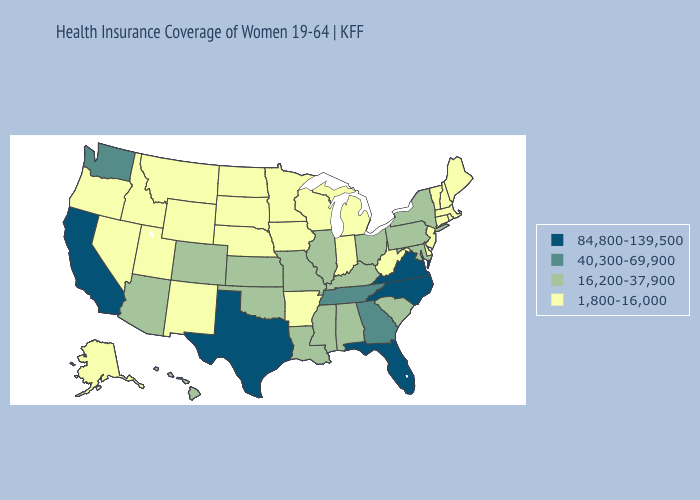What is the value of Idaho?
Quick response, please. 1,800-16,000. Does Rhode Island have the lowest value in the USA?
Give a very brief answer. Yes. Does Maine have the highest value in the USA?
Answer briefly. No. Does Connecticut have a lower value than Utah?
Keep it brief. No. Does Alabama have the lowest value in the USA?
Be succinct. No. What is the value of Nebraska?
Write a very short answer. 1,800-16,000. What is the highest value in the MidWest ?
Answer briefly. 16,200-37,900. Name the states that have a value in the range 16,200-37,900?
Be succinct. Alabama, Arizona, Colorado, Hawaii, Illinois, Kansas, Kentucky, Louisiana, Maryland, Mississippi, Missouri, New York, Ohio, Oklahoma, Pennsylvania, South Carolina. What is the value of Oregon?
Answer briefly. 1,800-16,000. What is the lowest value in states that border Nevada?
Quick response, please. 1,800-16,000. How many symbols are there in the legend?
Write a very short answer. 4. Name the states that have a value in the range 16,200-37,900?
Give a very brief answer. Alabama, Arizona, Colorado, Hawaii, Illinois, Kansas, Kentucky, Louisiana, Maryland, Mississippi, Missouri, New York, Ohio, Oklahoma, Pennsylvania, South Carolina. What is the value of Oklahoma?
Keep it brief. 16,200-37,900. Which states have the lowest value in the USA?
Write a very short answer. Alaska, Arkansas, Connecticut, Delaware, Idaho, Indiana, Iowa, Maine, Massachusetts, Michigan, Minnesota, Montana, Nebraska, Nevada, New Hampshire, New Jersey, New Mexico, North Dakota, Oregon, Rhode Island, South Dakota, Utah, Vermont, West Virginia, Wisconsin, Wyoming. Name the states that have a value in the range 1,800-16,000?
Concise answer only. Alaska, Arkansas, Connecticut, Delaware, Idaho, Indiana, Iowa, Maine, Massachusetts, Michigan, Minnesota, Montana, Nebraska, Nevada, New Hampshire, New Jersey, New Mexico, North Dakota, Oregon, Rhode Island, South Dakota, Utah, Vermont, West Virginia, Wisconsin, Wyoming. 